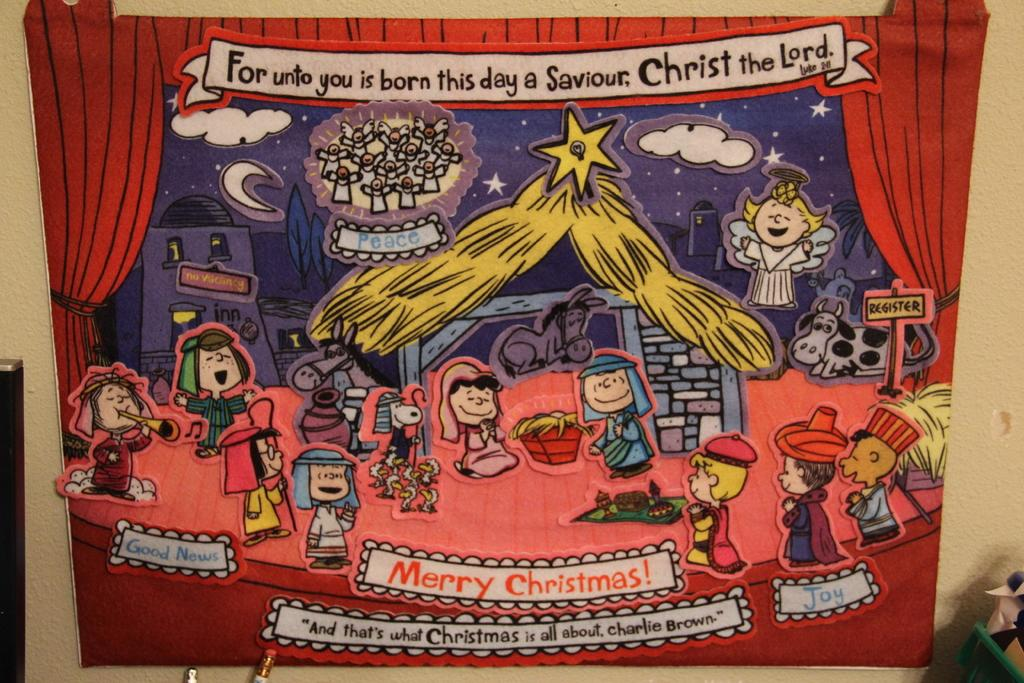<image>
Provide a brief description of the given image. A cartoon drawing that is about Christmas and mentions the character Charlie Brown. 